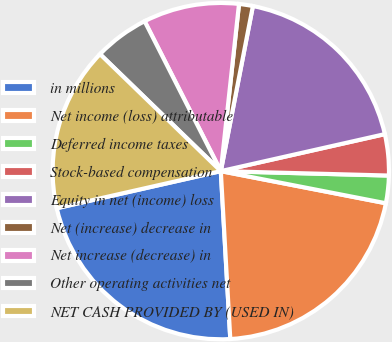Convert chart to OTSL. <chart><loc_0><loc_0><loc_500><loc_500><pie_chart><fcel>in millions<fcel>Net income (loss) attributable<fcel>Deferred income taxes<fcel>Stock-based compensation<fcel>Equity in net (income) loss<fcel>Net (increase) decrease in<fcel>Net increase (decrease) in<fcel>Other operating activities net<fcel>NET CASH PROVIDED BY (USED IN)<nl><fcel>22.36%<fcel>21.04%<fcel>2.64%<fcel>3.95%<fcel>18.41%<fcel>1.33%<fcel>9.21%<fcel>5.27%<fcel>15.78%<nl></chart> 